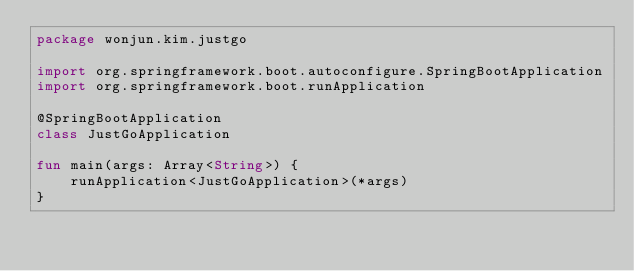Convert code to text. <code><loc_0><loc_0><loc_500><loc_500><_Kotlin_>package wonjun.kim.justgo

import org.springframework.boot.autoconfigure.SpringBootApplication
import org.springframework.boot.runApplication

@SpringBootApplication
class JustGoApplication

fun main(args: Array<String>) {
    runApplication<JustGoApplication>(*args)
}
</code> 